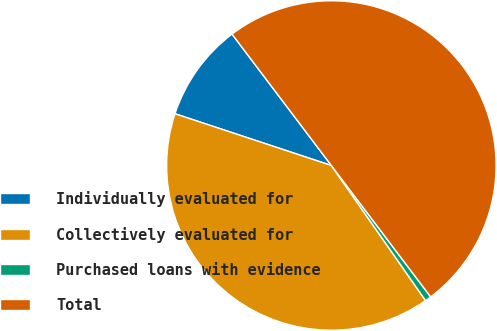Convert chart to OTSL. <chart><loc_0><loc_0><loc_500><loc_500><pie_chart><fcel>Individually evaluated for<fcel>Collectively evaluated for<fcel>Purchased loans with evidence<fcel>Total<nl><fcel>9.61%<fcel>39.78%<fcel>0.61%<fcel>50.0%<nl></chart> 